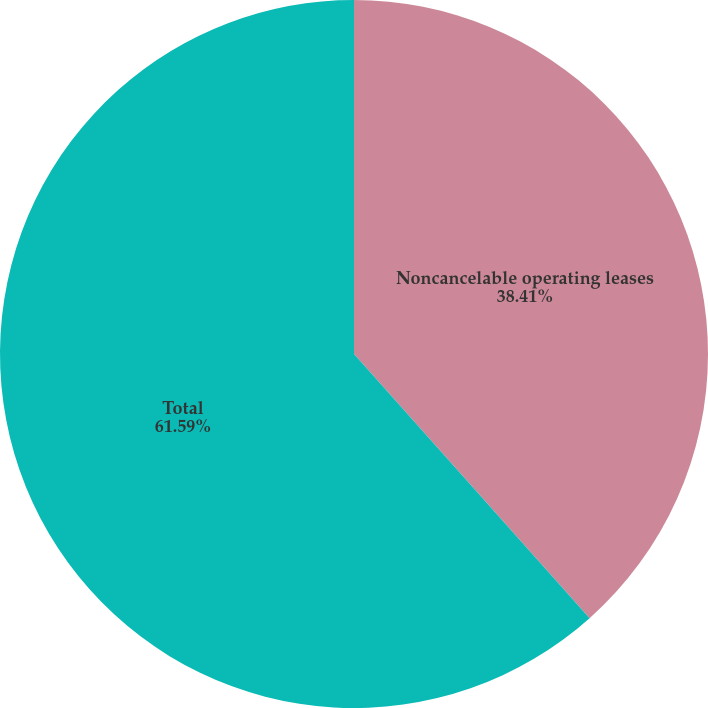<chart> <loc_0><loc_0><loc_500><loc_500><pie_chart><fcel>Noncancelable operating leases<fcel>Total<nl><fcel>38.41%<fcel>61.59%<nl></chart> 